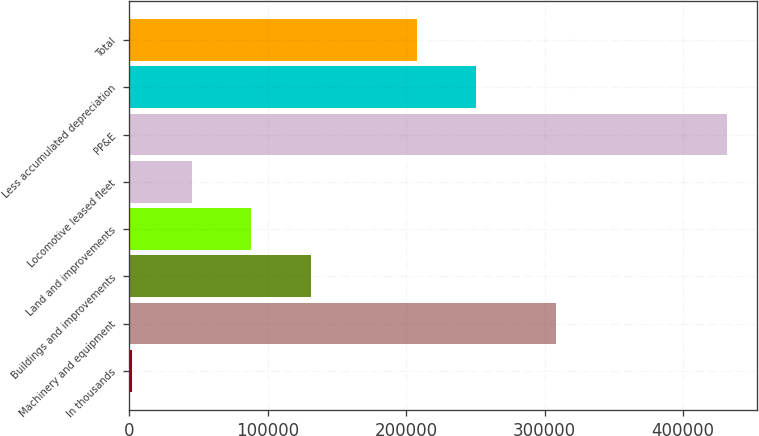Convert chart to OTSL. <chart><loc_0><loc_0><loc_500><loc_500><bar_chart><fcel>In thousands<fcel>Machinery and equipment<fcel>Buildings and improvements<fcel>Land and improvements<fcel>Locomotive leased fleet<fcel>PP&E<fcel>Less accumulated depreciation<fcel>Total<nl><fcel>2008<fcel>308189<fcel>130887<fcel>87927.2<fcel>44967.6<fcel>431604<fcel>250508<fcel>207548<nl></chart> 